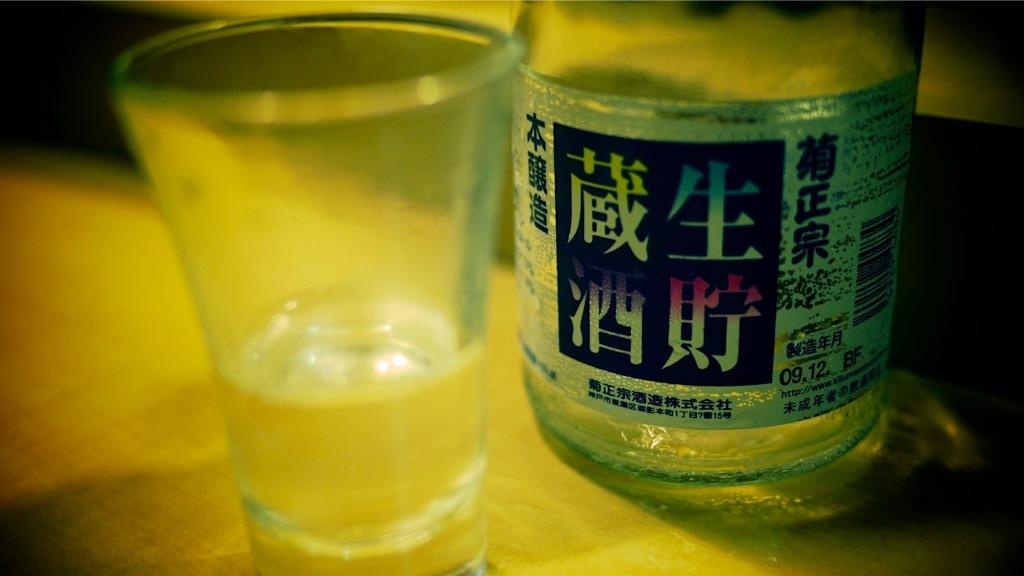Provide a one-sentence caption for the provided image. Bottle of a clear liquor that has in black writing 09.12. BF. 